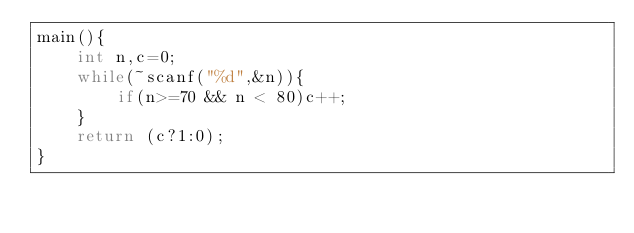<code> <loc_0><loc_0><loc_500><loc_500><_C_>main(){
	int n,c=0;
	while(~scanf("%d",&n)){
		if(n>=70 && n < 80)c++;
	}
	return (c?1:0);
}</code> 